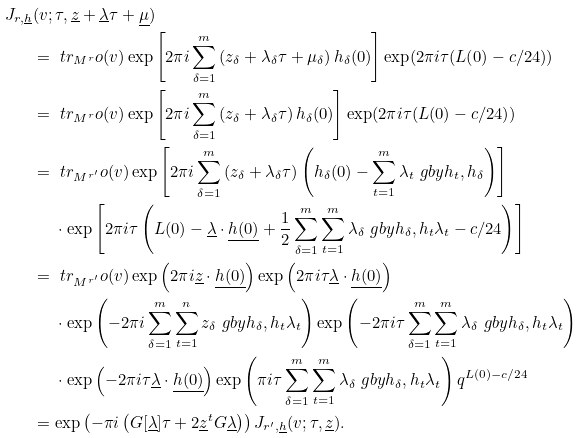<formula> <loc_0><loc_0><loc_500><loc_500>J _ { r , \underline { h } } & ( v ; \tau , \underline { z } + \underline { \lambda } \tau + \underline { \mu } ) \\ & = \ t r _ { M ^ { r } } o ( v ) \exp \left [ 2 \pi i \sum _ { \delta = 1 } ^ { m } \left ( z _ { \delta } + \lambda _ { \delta } \tau + \mu _ { \delta } \right ) h _ { \delta } ( 0 ) \right ] \exp ( 2 \pi i \tau ( L ( 0 ) - c / 2 4 ) ) \\ & = \ t r _ { M ^ { r } } o ( v ) \exp \left [ 2 \pi i \sum _ { \delta = 1 } ^ { m } \left ( z _ { \delta } + \lambda _ { \delta } \tau \right ) h _ { \delta } ( 0 ) \right ] \exp ( 2 \pi i \tau ( L ( 0 ) - c / 2 4 ) ) \\ & = \ t r _ { M ^ { r ^ { \prime } } } o ( v ) \exp \left [ 2 \pi i \sum _ { \delta = 1 } ^ { m } \left ( z _ { \delta } + \lambda _ { \delta } \tau \right ) \left ( h _ { \delta } ( 0 ) - \sum _ { t = 1 } ^ { m } \lambda _ { t } \ g b y { h _ { t } , h _ { \delta } } \right ) \right ] \\ & \quad \ \cdot \exp \left [ 2 \pi i \tau \left ( L ( 0 ) - \underline { \lambda } \cdot \underline { h ( 0 ) } + \frac { 1 } { 2 } \sum _ { \delta = 1 } ^ { m } \sum _ { t = 1 } ^ { m } \lambda _ { \delta } \ g b y { h _ { \delta } , h _ { t } } \lambda _ { t } - c / 2 4 \right ) \right ] \\ & = \ t r _ { M ^ { r ^ { \prime } } } o ( v ) \exp \left ( 2 \pi i \underline { z } \cdot \underline { h ( 0 ) } \right ) \exp \left ( 2 \pi i \tau \underline { \lambda } \cdot \underline { h ( 0 ) } \right ) \\ & \quad \ \cdot \exp \left ( - 2 \pi i \sum _ { \delta = 1 } ^ { m } \sum _ { t = 1 } ^ { n } z _ { \delta } \ g b y { h _ { \delta } , h _ { t } } \lambda _ { t } \right ) \exp \left ( - 2 \pi i \tau \sum _ { \delta = 1 } ^ { m } \sum _ { t = 1 } ^ { m } \lambda _ { \delta } \ g b y { h _ { \delta } , h _ { t } } \lambda _ { t } \right ) \\ & \quad \ \cdot \exp \left ( - 2 \pi i \tau \underline { \lambda } \cdot \underline { h ( 0 ) } \right ) \exp \left ( \pi i \tau \sum _ { \delta = 1 } ^ { m } \sum _ { t = 1 } ^ { m } \lambda _ { \delta } \ g b y { h _ { \delta } , h _ { t } } \lambda _ { t } \right ) q ^ { L ( 0 ) - c / 2 4 } \\ & = \exp \left ( - \pi i \left ( G [ \underline { \lambda } ] \tau + 2 \underline { z } ^ { t } G \underline { \lambda } \right ) \right ) J _ { r ^ { \prime } , \underline { h } } ( v ; \tau , \underline { z } ) .</formula> 